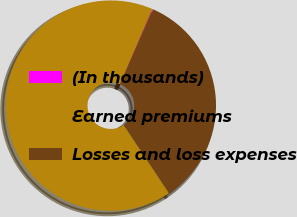<chart> <loc_0><loc_0><loc_500><loc_500><pie_chart><fcel>(In thousands)<fcel>Earned premiums<fcel>Losses and loss expenses<nl><fcel>0.11%<fcel>65.81%<fcel>34.08%<nl></chart> 